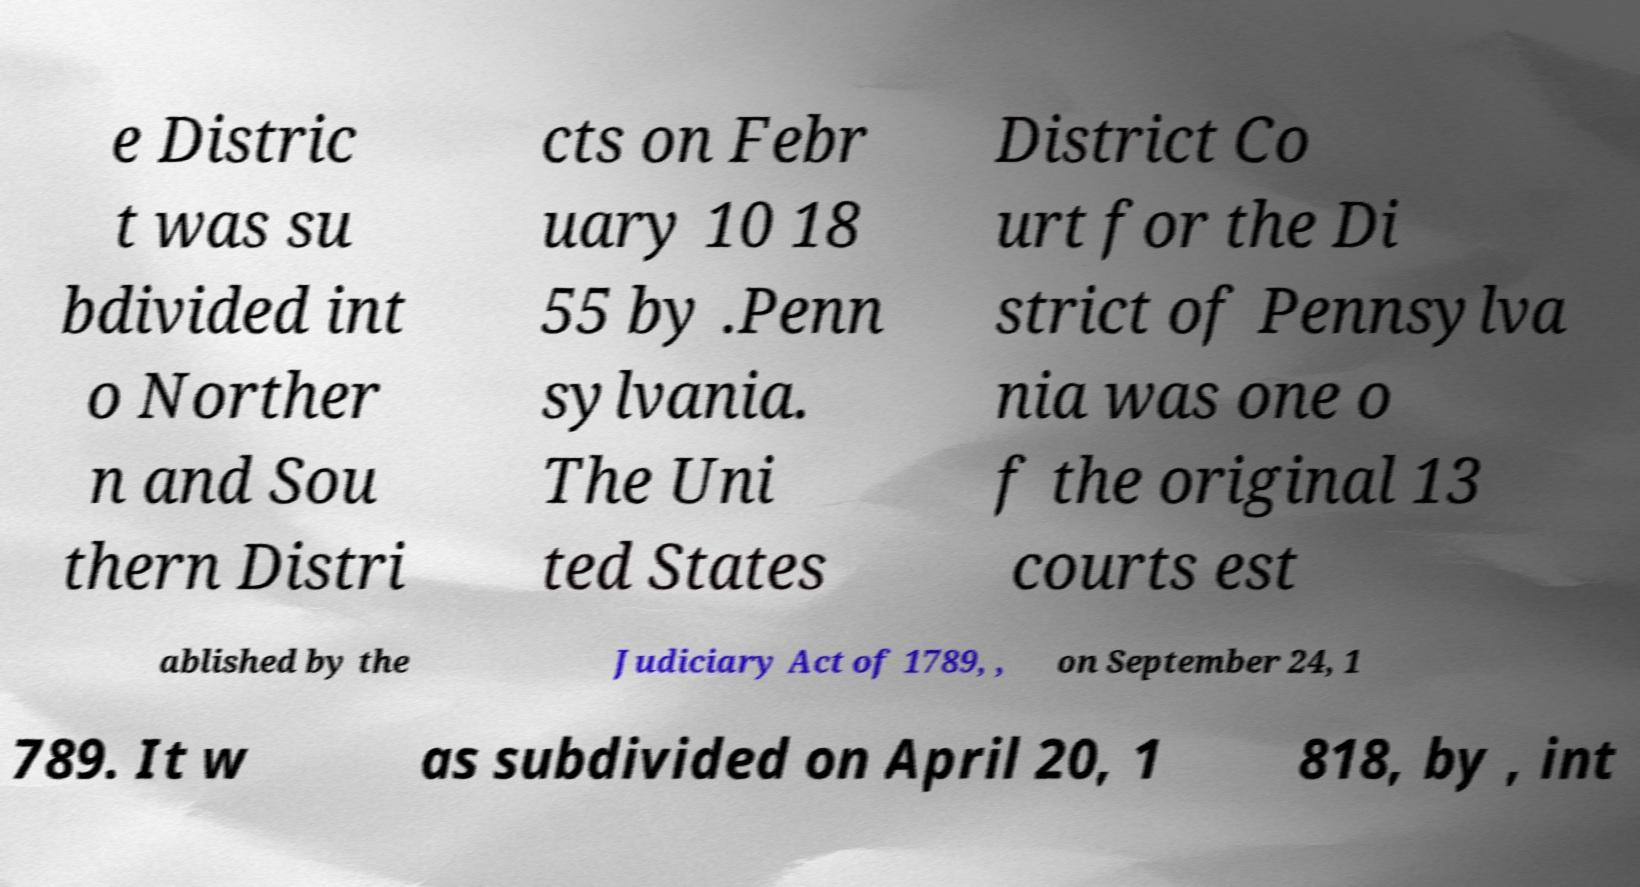Could you extract and type out the text from this image? e Distric t was su bdivided int o Norther n and Sou thern Distri cts on Febr uary 10 18 55 by .Penn sylvania. The Uni ted States District Co urt for the Di strict of Pennsylva nia was one o f the original 13 courts est ablished by the Judiciary Act of 1789, , on September 24, 1 789. It w as subdivided on April 20, 1 818, by , int 